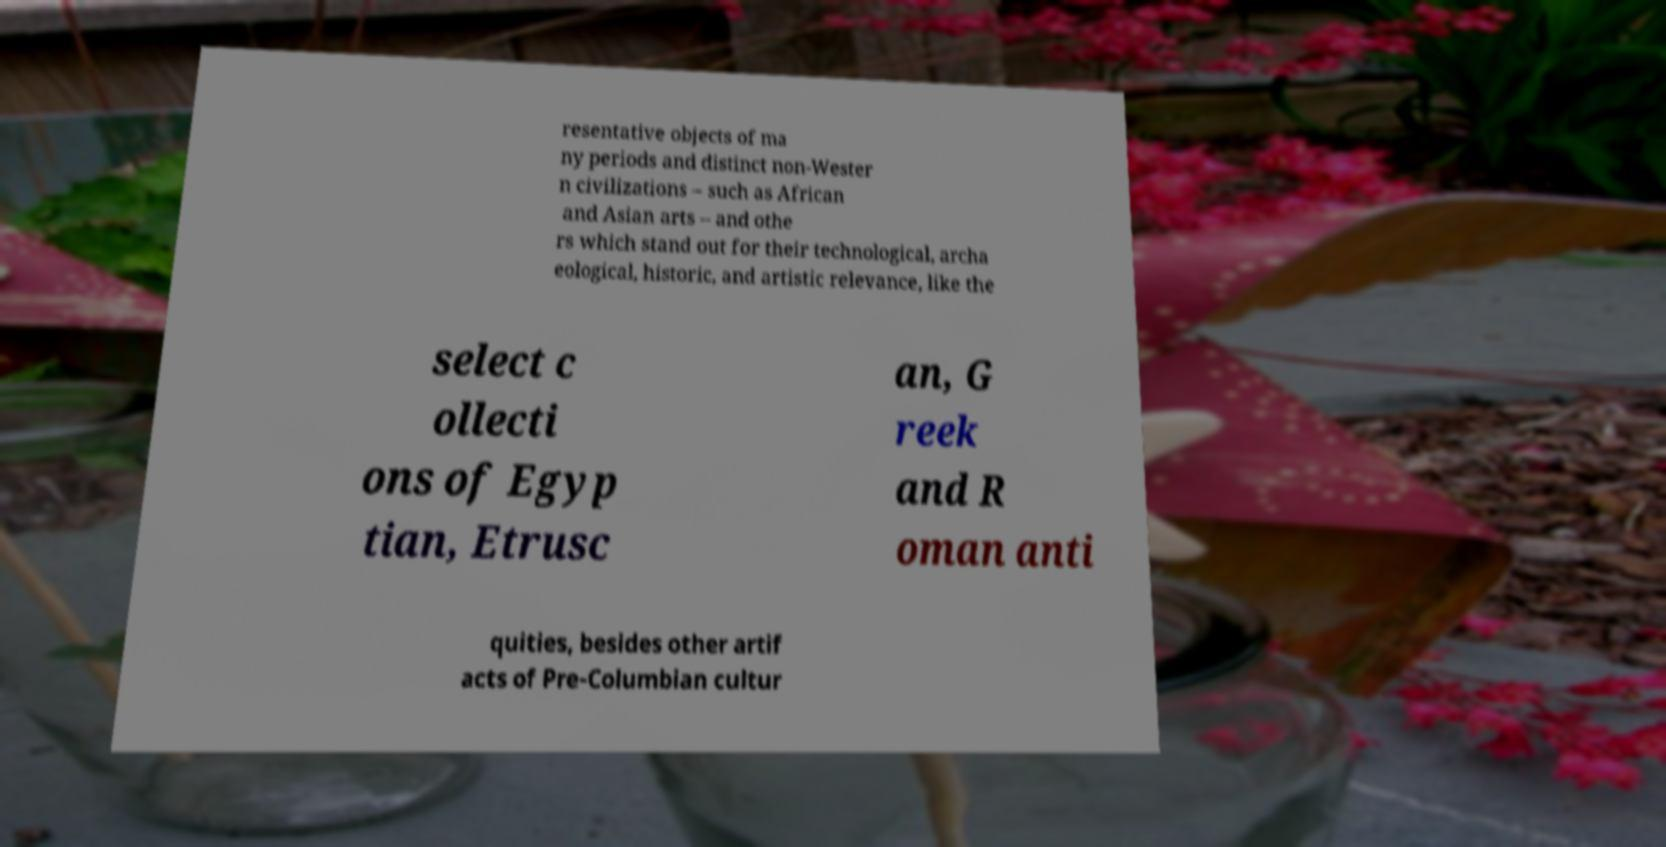Please identify and transcribe the text found in this image. resentative objects of ma ny periods and distinct non-Wester n civilizations – such as African and Asian arts – and othe rs which stand out for their technological, archa eological, historic, and artistic relevance, like the select c ollecti ons of Egyp tian, Etrusc an, G reek and R oman anti quities, besides other artif acts of Pre-Columbian cultur 